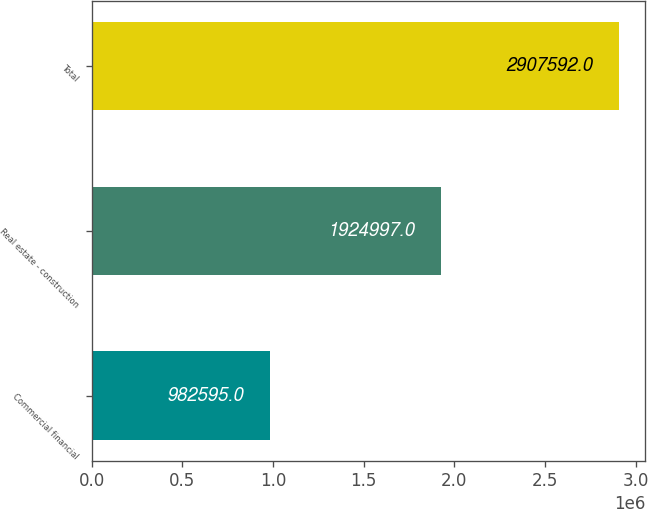Convert chart. <chart><loc_0><loc_0><loc_500><loc_500><bar_chart><fcel>Commercial financial<fcel>Real estate - construction<fcel>Total<nl><fcel>982595<fcel>1.925e+06<fcel>2.90759e+06<nl></chart> 